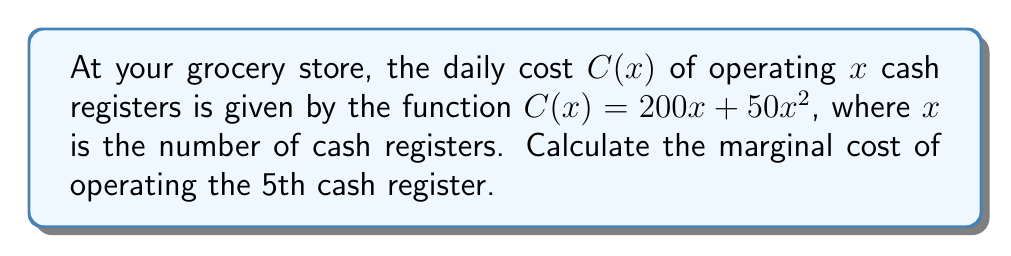Help me with this question. To find the marginal cost, we need to calculate the derivative of the cost function and evaluate it at $x = 5$. Here's how we do it:

1. The cost function is $C(x) = 200x + 50x^2$

2. To find the derivative, we use the power rule and constant multiple rule:
   $$\frac{d}{dx}C(x) = \frac{d}{dx}(200x + 50x^2) = 200 + 100x$$

3. This derivative function represents the marginal cost for any number of cash registers.

4. To find the marginal cost of the 5th cash register, we evaluate the derivative at $x = 5$:
   $$\frac{d}{dx}C(5) = 200 + 100(5) = 200 + 500 = 700$$

5. Therefore, the marginal cost of operating the 5th cash register is $700.

This means that adding the 5th cash register would increase the total daily operating cost by $700.
Answer: $700 